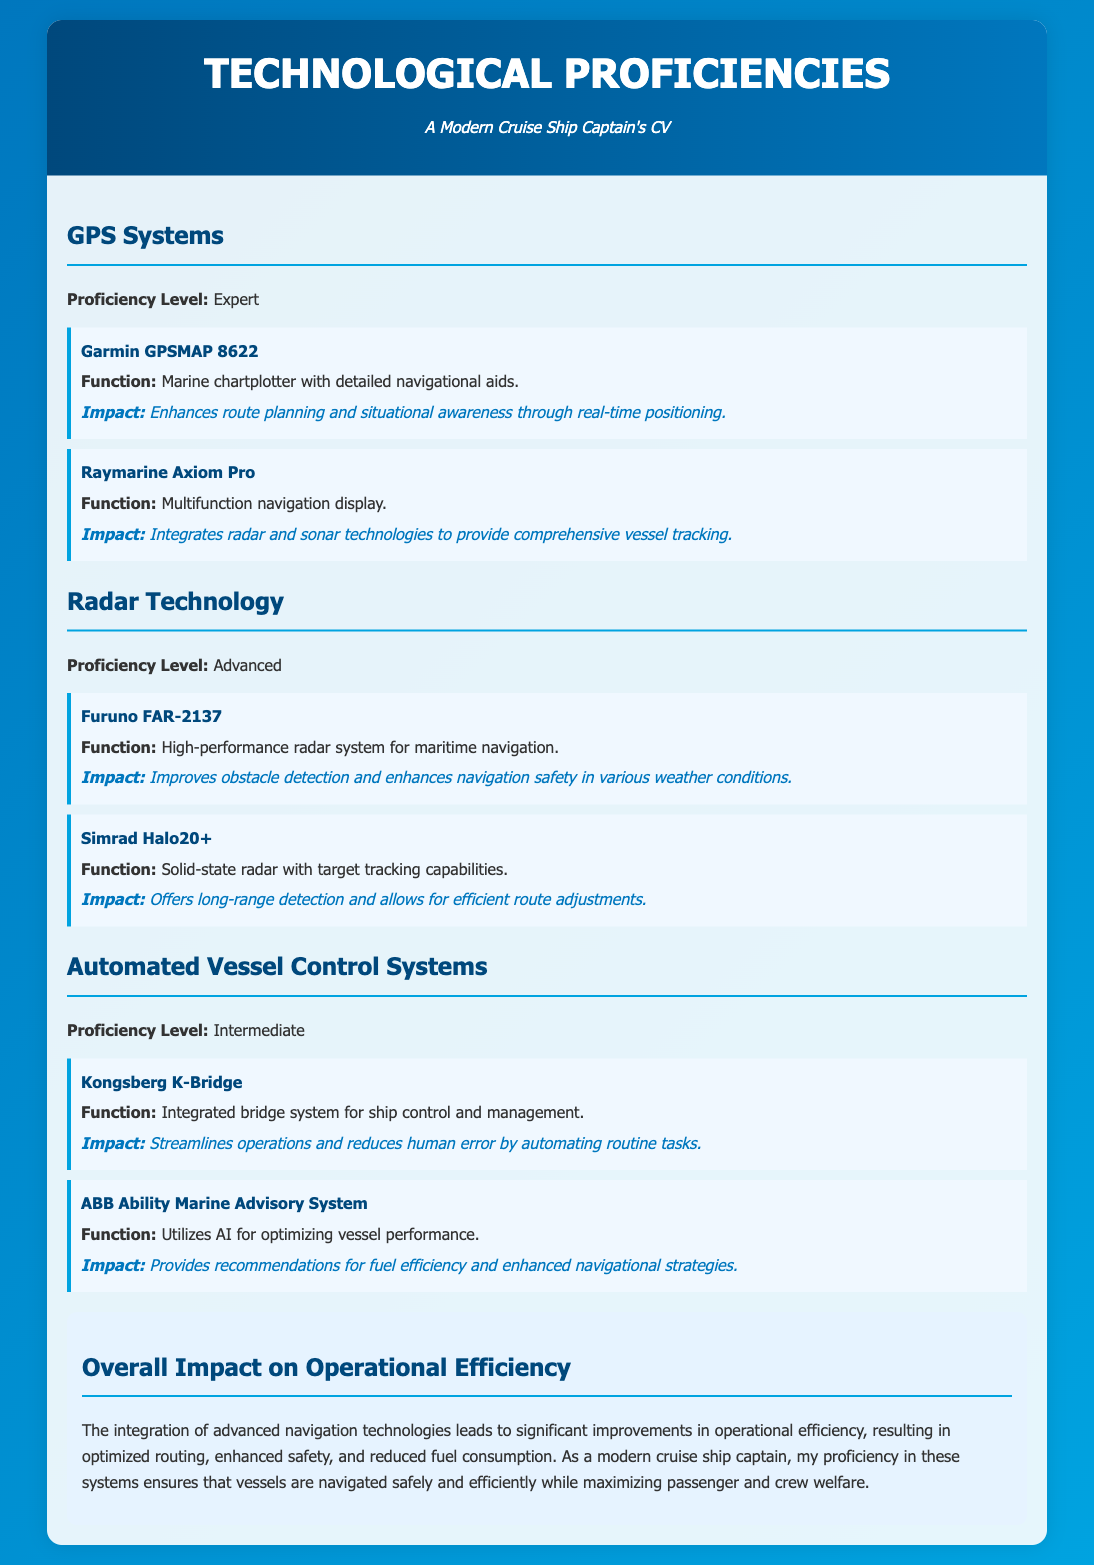What is the proficiency level in GPS systems? The proficiency level is explicitly stated as "Expert."
Answer: Expert What tool is mentioned under Radar Technology? The document lists "Furuno FAR-2137" under this section.
Answer: Furuno FAR-2137 What is the main function of the Kongsberg K-Bridge? The function is described as "Integrated bridge system for ship control and management."
Answer: Integrated bridge system for ship control and management What impact does the Raymarine Axiom Pro have? The document notes that it "integrates radar and sonar technologies to provide comprehensive vessel tracking."
Answer: Integrates radar and sonar technologies to provide comprehensive vessel tracking What is the overall impact of advanced navigation technologies on operational efficiency? It mentions "significant improvements in operational efficiency, resulting in optimized routing, enhanced safety, and reduced fuel consumption."
Answer: Significant improvements in operational efficiency What technology utilizes AI for optimizing vessel performance? The ABB Ability Marine Advisory System is the technology mentioned for this purpose.
Answer: ABB Ability Marine Advisory System What color is used for section headings in the document? Section headings are described to have a color of "#00487c."
Answer: #00487c How many tools are listed under Automated Vessel Control Systems? The document specifies that there are "two tools" listed in this section.
Answer: Two tools 